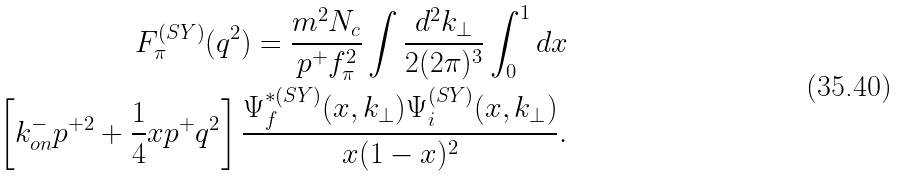Convert formula to latex. <formula><loc_0><loc_0><loc_500><loc_500>F _ { \pi } ^ { ( S Y ) } ( q ^ { 2 } ) = \frac { m ^ { 2 } N _ { c } } { p ^ { + } f _ { \pi } ^ { 2 } } \int \frac { d ^ { 2 } k _ { \perp } } { 2 ( 2 \pi ) ^ { 3 } } \int _ { 0 } ^ { 1 } d x \\ \left [ k ^ { - } _ { o n } p ^ { + 2 } + \frac { 1 } { 4 } x p ^ { + } q ^ { 2 } \right ] \frac { \Psi ^ { * ( S Y ) } _ { f } ( x , k _ { \perp } ) \Psi ^ { ( S Y ) } _ { i } ( x , k _ { \perp } ) } { x ( 1 - x ) ^ { 2 } } .</formula> 